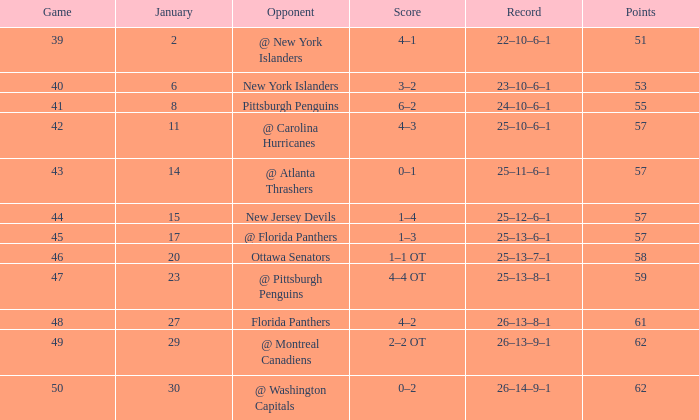Which competitor has an average below 62 and a january average under 6? @ New York Islanders. 